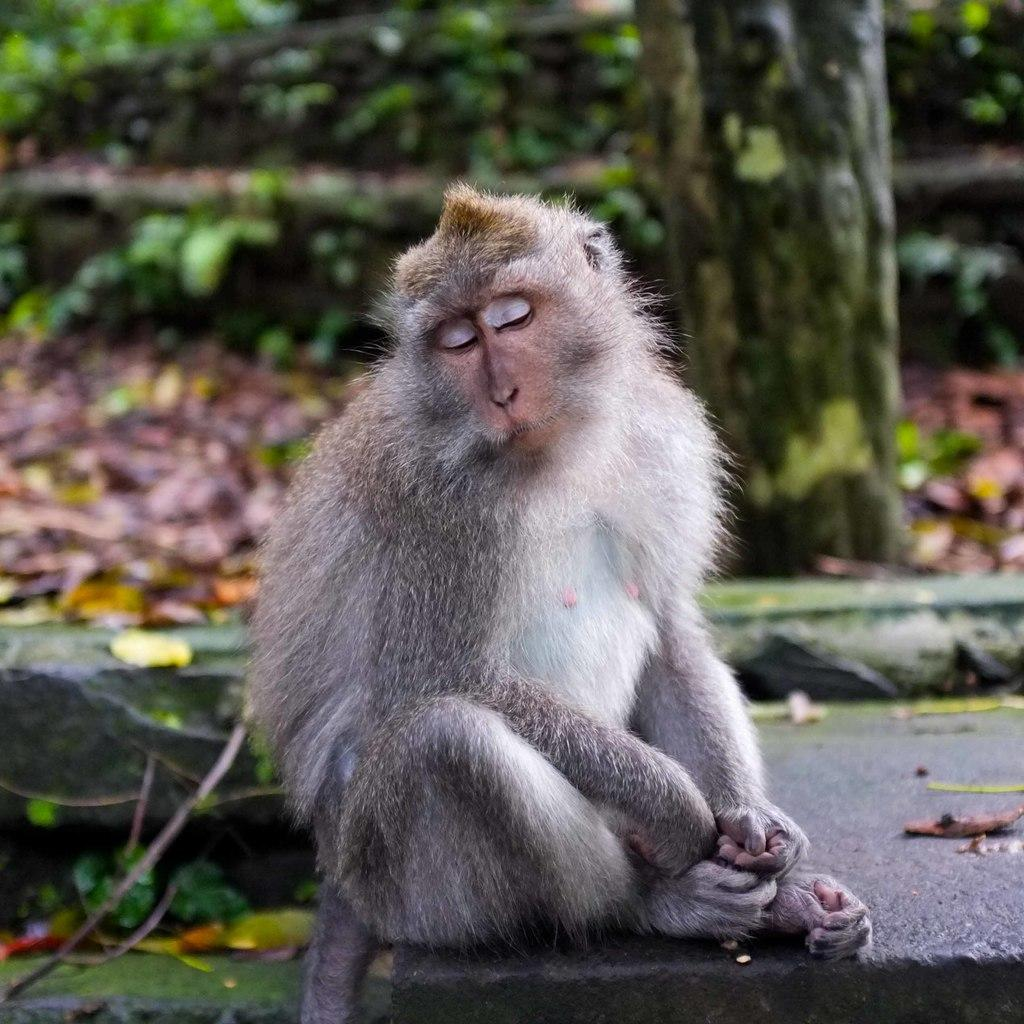What animal is sitting on a surface in the image? There is a monkey sitting on a surface in the image. Where is the monkey located in the image? The monkey is at the bottom of the image. What type of material can be seen on the right side of the image? There is tree bark visible on the right side of the image. Can you see a kite flying in the image? There is no kite visible in the image. What type of creature is flying in the image? There are no creatures flying in the image; the only animal mentioned is the monkey, which is sitting on a surface. 